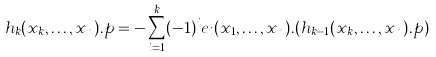Convert formula to latex. <formula><loc_0><loc_0><loc_500><loc_500>h _ { k } ( x _ { k } , \dots , x _ { n } ) . p = - \sum _ { i = 1 } ^ { k } ( - 1 ) ^ { i } e _ { i } ( x _ { 1 } , \dots , x _ { n } ) . ( h _ { k - 1 } ( x _ { k } , \dots , x _ { n } ) . p )</formula> 